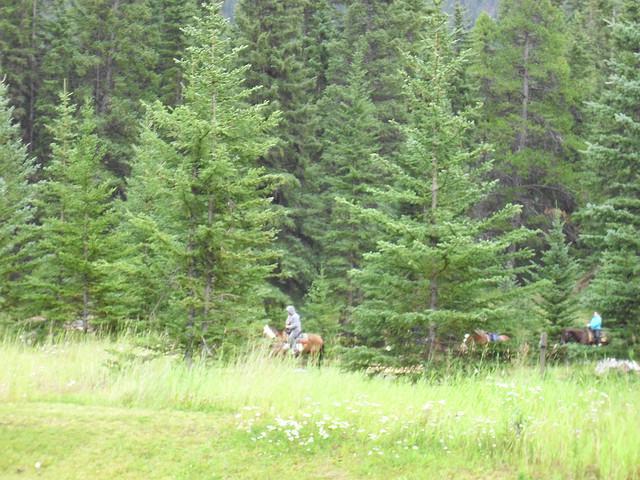How many zebras are there?
Give a very brief answer. 0. 